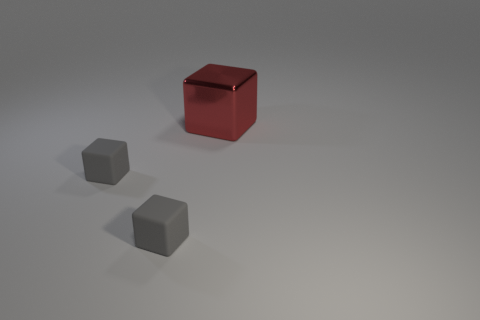How many blocks are the same color as the metallic thing?
Make the answer very short. 0. What size is the red metal object?
Offer a very short reply. Large. Is the number of large metallic cubes that are to the left of the big red shiny cube less than the number of big red cubes?
Your response must be concise. Yes. Is there any other thing that has the same shape as the big red object?
Ensure brevity in your answer.  Yes. Is the number of rubber things less than the number of large brown rubber spheres?
Offer a very short reply. No. Is the number of gray things greater than the number of big red shiny objects?
Your answer should be compact. Yes. What number of things are either things on the left side of the large red metal cube or small gray rubber blocks?
Your response must be concise. 2. What number of objects are either objects that are left of the metal cube or things that are on the left side of the large metal thing?
Your answer should be compact. 2. Is there any other thing that has the same size as the red metal cube?
Your answer should be compact. No. How many objects are tiny gray things or red metallic things?
Your answer should be very brief. 3. 